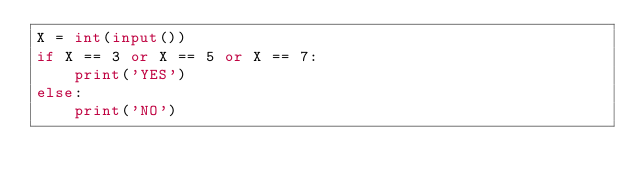Convert code to text. <code><loc_0><loc_0><loc_500><loc_500><_Python_>X = int(input())
if X == 3 or X == 5 or X == 7:
    print('YES')
else:
    print('NO')</code> 